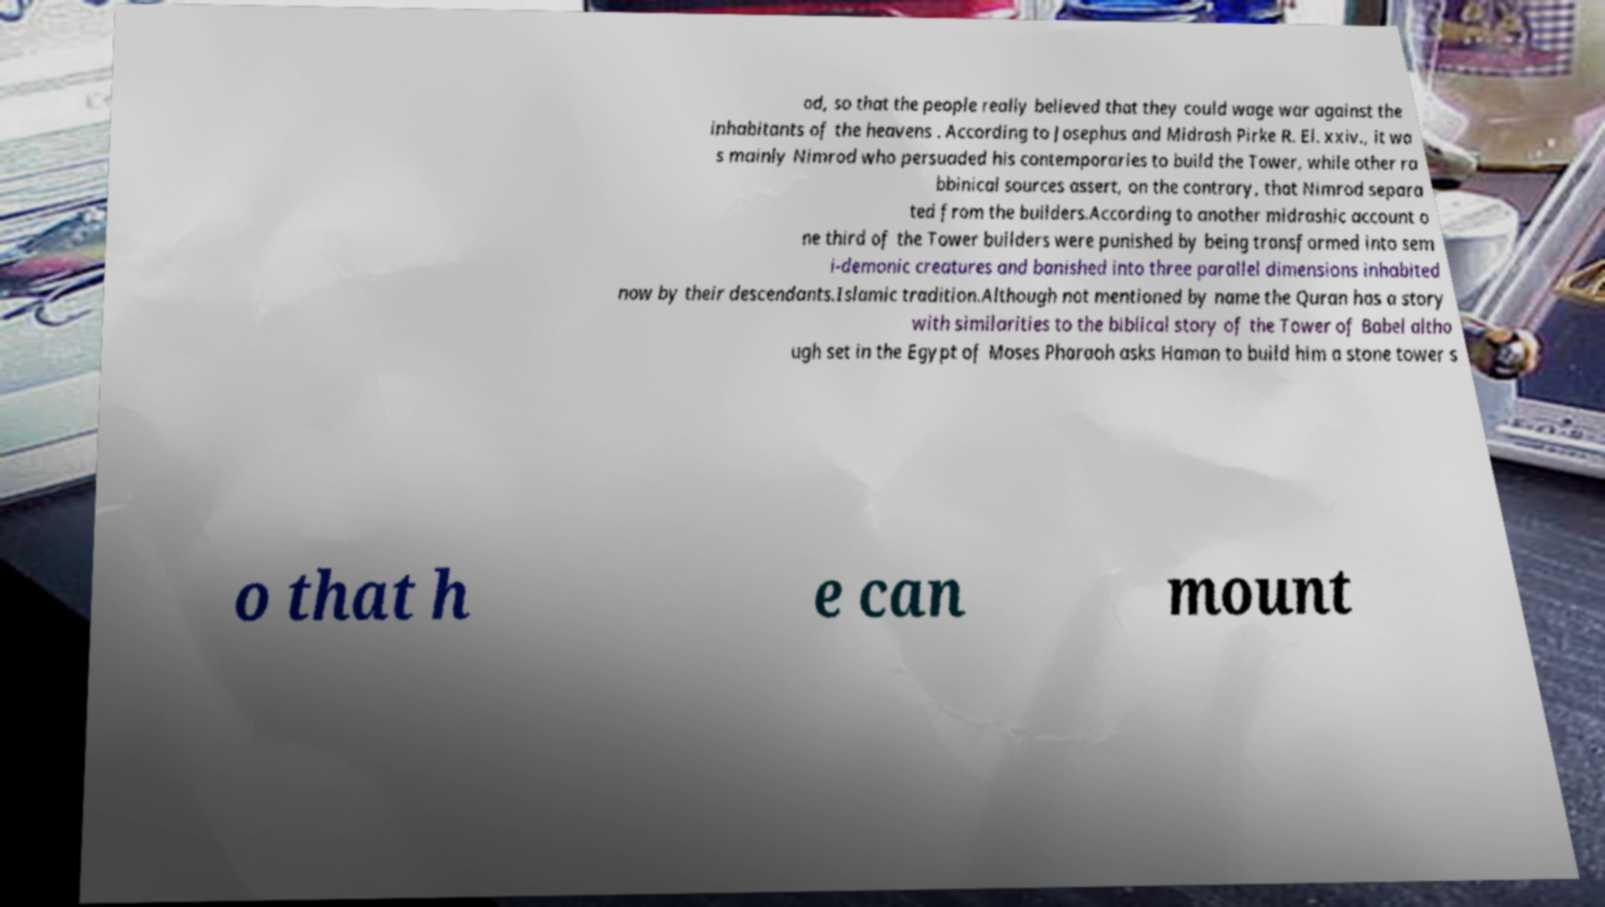Please identify and transcribe the text found in this image. od, so that the people really believed that they could wage war against the inhabitants of the heavens . According to Josephus and Midrash Pirke R. El. xxiv., it wa s mainly Nimrod who persuaded his contemporaries to build the Tower, while other ra bbinical sources assert, on the contrary, that Nimrod separa ted from the builders.According to another midrashic account o ne third of the Tower builders were punished by being transformed into sem i-demonic creatures and banished into three parallel dimensions inhabited now by their descendants.Islamic tradition.Although not mentioned by name the Quran has a story with similarities to the biblical story of the Tower of Babel altho ugh set in the Egypt of Moses Pharaoh asks Haman to build him a stone tower s o that h e can mount 